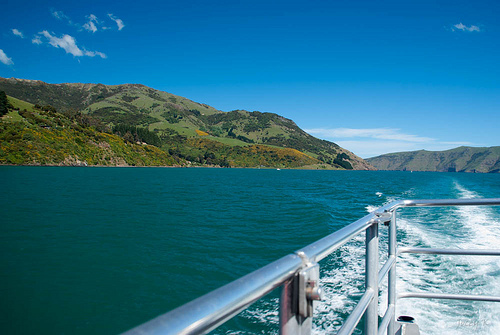<image>
Can you confirm if the trees is on the mountain? Yes. Looking at the image, I can see the trees is positioned on top of the mountain, with the mountain providing support. Is there a water under the mountain? No. The water is not positioned under the mountain. The vertical relationship between these objects is different. 